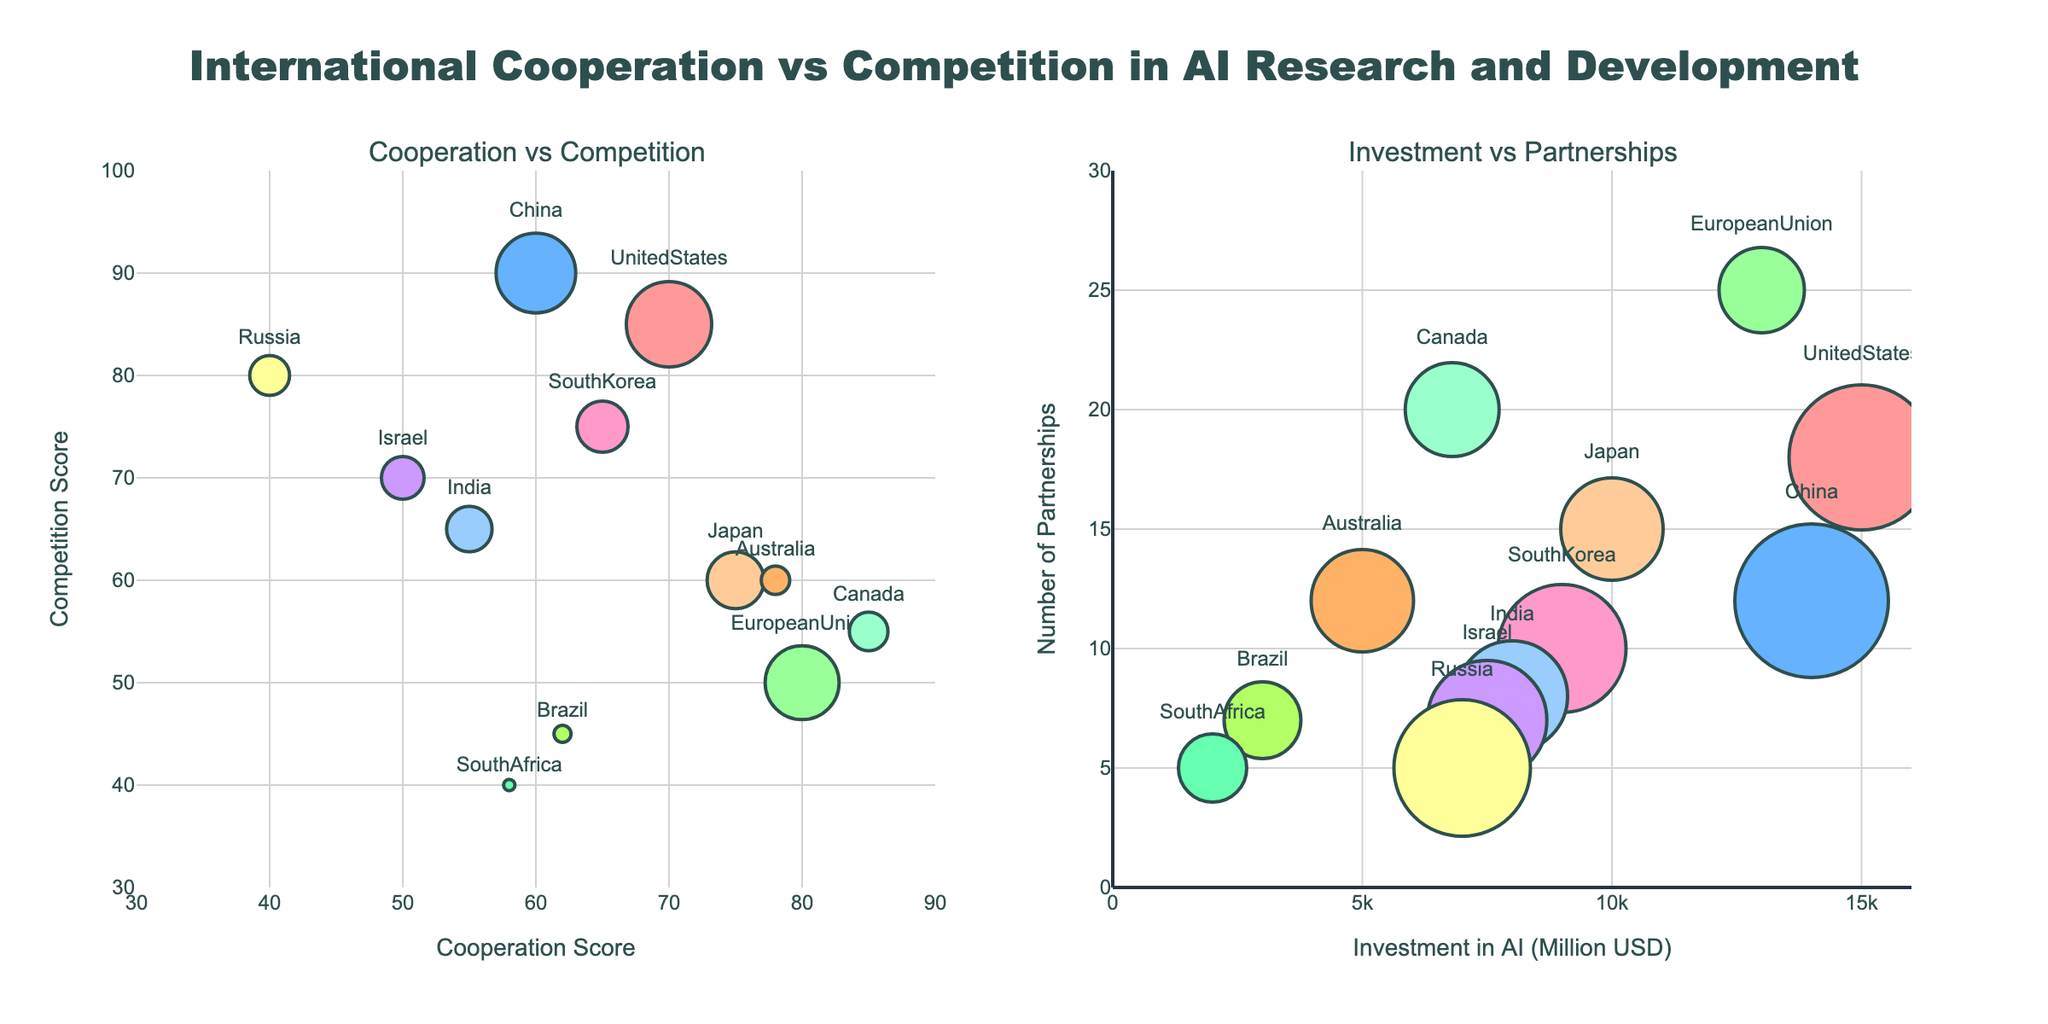What is the title of the figure? The title is displayed at the top center of the figure in larger, bold text. It helps to understand the overall theme or subject of the visual representation.
Answer: International Cooperation vs Competition in AI Research and Development Which country has the highest cooperation score? By observing the x-axis on the left subplot (Cooperation vs Competition), the highest cooperation score is represented by the data point farthest to the right.
Answer: Canada Which country has the highest competition score? By observing the y-axis on the left subplot (Cooperation vs Competition), the highest competition score is represented by the highest data point on the chart.
Answer: China Which country has the largest investment in AI? By looking at both subplots, the country with the largest bubble (markers size) in the first subplot (Cooperation vs Competition) indicates the highest investment in AI.
Answer: United States What is the relationship between investment in AI and the number of partnerships for Canada? On the right subplot (Investment vs Partnerships), locate the point labeled "Canada," and observe its position relative to the x-axis (Investment in AI) and y-axis (Number of Partnerships).
Answer: Canada has an AI investment of 6800 million USD and 20 partnerships Which country has the least number of partnerships and what is their competition score? On the right subplot (Investment vs Partnerships), the point with the lowest value on the y-axis represents the least number of partnerships. Then, refer to the corresponding competition score on the left subplot (Cooperation vs Competition) for that country.
Answer: Russia, competition score is 80 How do the cooperation scores of Japan and South Korea compare? By locating the points labeled "Japan" and "South Korea" on the left subplot (Cooperation vs Competition), compare their positions along the x-axis.
Answer: Japan has a higher cooperation score (75) than South Korea (65) Which country on the right subplot has the same color as a country with a bubble size close to 70 on the left subplot? Look for a country on the right subplot (Investment vs Partnerships) with the same color as a bubble of approximately 70 size on the left subplot (Cooperation vs Competition).
Answer: Israel (left subplot) and Russia (right subplot) have the same colors What is the sum of the investment in AI for China and Japan? Observe the investment values for China and Japan on the right subplot (Investment vs Partnerships) and add them together.
Answer: 14000 million USD (China) + 10000 million USD (Japan) = 24000 million USD Which country has the greatest competition score with fewer than 10 partnerships? Look at the right subplot (Investment vs Partnerships) for countries with fewer than 10 points on the y-axis and find the one with the maximum competition score on the left subplot (Cooperation vs Competition).
Answer: Russia has the greatest competition score (80) with fewer than 10 partnerships 